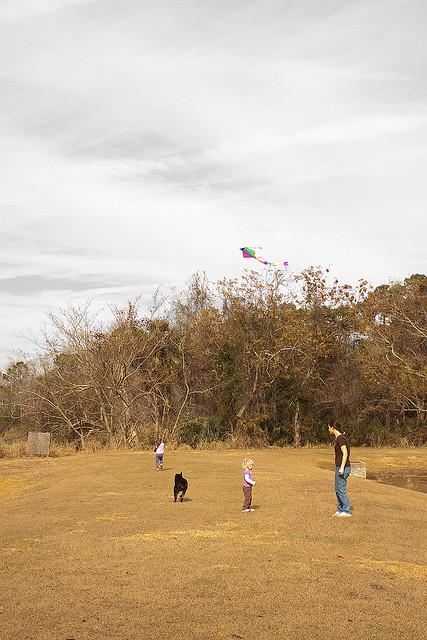Are they outside?
Give a very brief answer. Yes. What is in the air?
Be succinct. Kite. What animal is in the picture?
Keep it brief. Dog. 